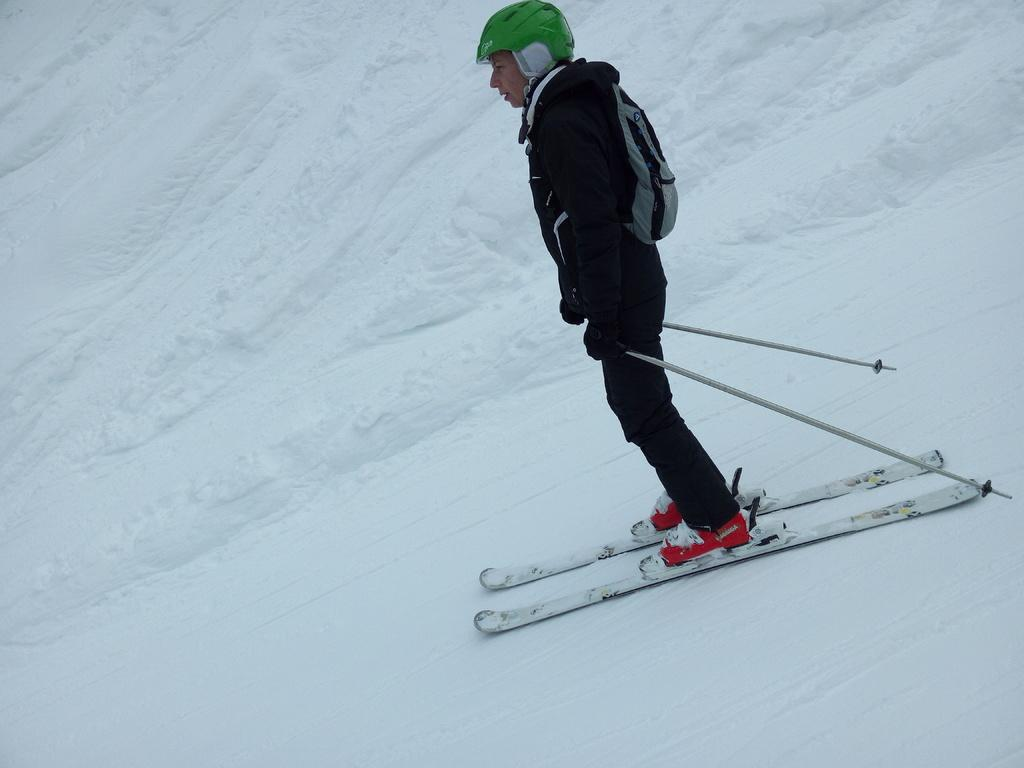What activity is the person in the image engaged in? The person is skiing in the image. What surface is the person skiing on? The person is skiing on snow. Can you describe the environment in the image? There is snow visible in the background of the image. What type of bulb is illuminating the person skiing in the image? There is no bulb present in the image; the person is skiing outdoors in a snowy environment. 